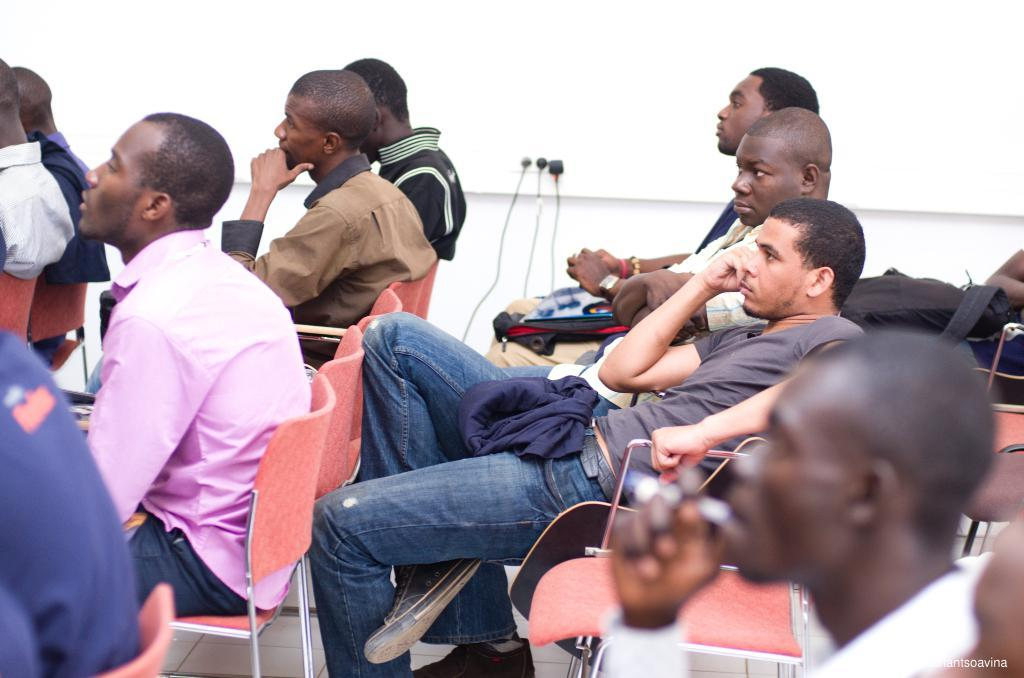How many people are in the image? There is a group of people in the image. What are the people doing in the image? The people are sitting on chairs. What can be seen in the background of the image? There is an off-white wall and sockets visible in the background of the image. Where was the image taken? The image was taken in a hall. What type of toothbrush is being used by the person in the image? There is no toothbrush present in the image; the people are sitting on chairs in a hall. What thought is being expressed by the person in the image? There is no indication of any thoughts being expressed by the people in the image, as it only shows them sitting on chairs in a hall. 